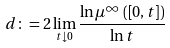<formula> <loc_0><loc_0><loc_500><loc_500>d \colon = 2 \lim _ { t \downarrow 0 } \frac { \ln \mu ^ { \infty } \left ( \left [ 0 , t \right ] \right ) } { \ln t }</formula> 